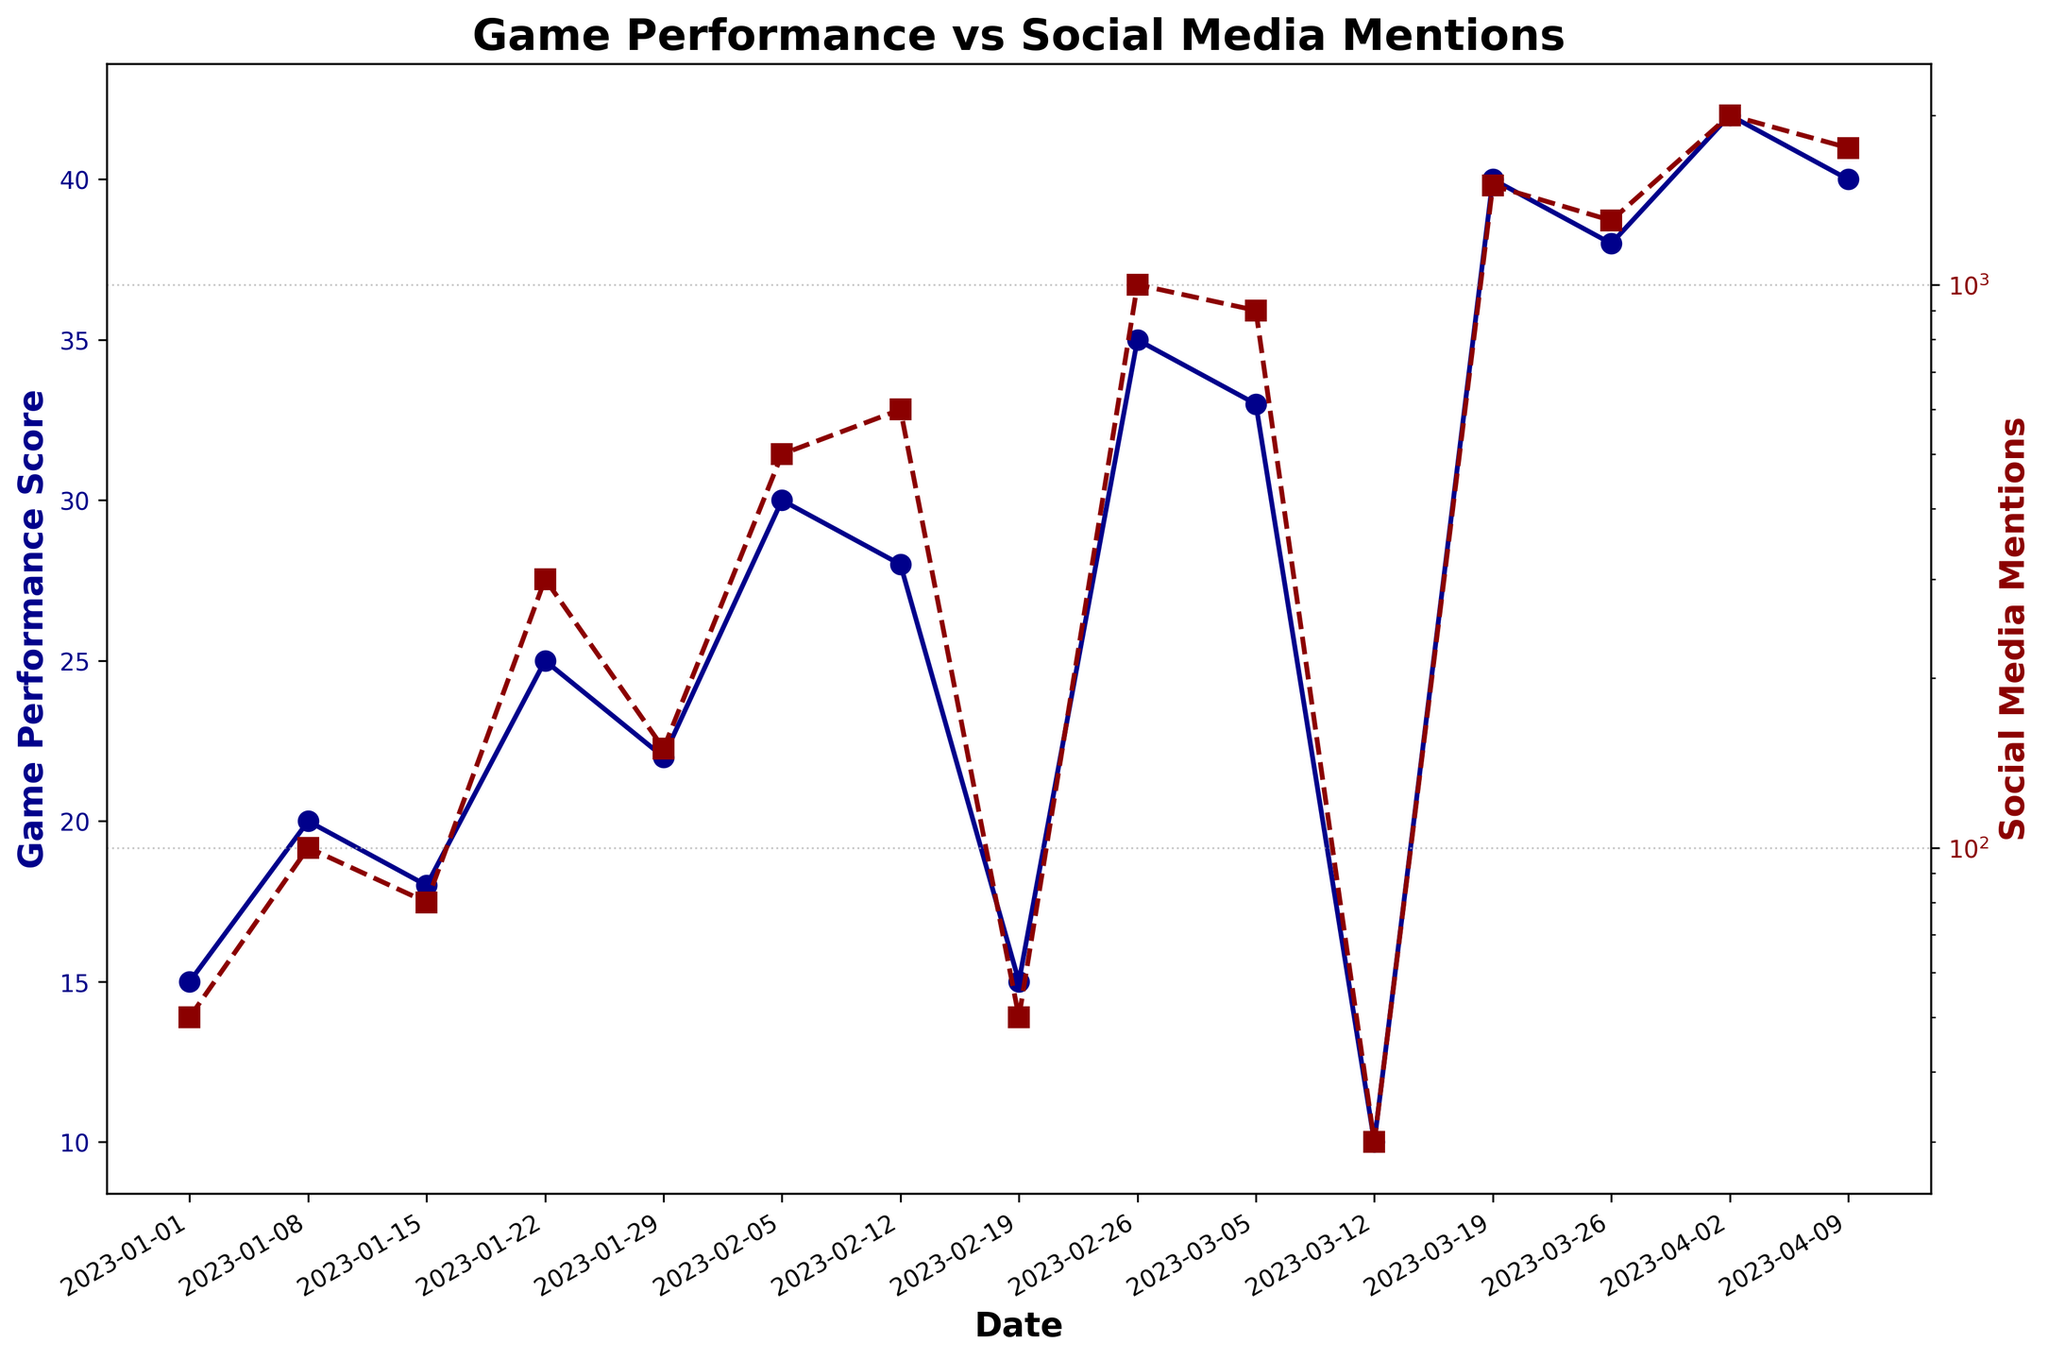what is the title of the figure? The title is typically at the top of the figure, styled in a larger and bolder font.
Answer: Game Performance vs Social Media Mentions How many data points are in the figure? Each date marks a data point, and you can count them along the x-axis.
Answer: 15 What is the highest "Game Performance Score" shown on the figure? Look at the y-axis corresponding to "Game Performance Score". The highest point visually can be identified among the points marked.
Answer: 42 Which date had the highest "Social Media Mentions"? Look at the "Social Media Mentions" line, and find the peak value. Match this peak with the date on the x-axis.
Answer: 2023-04-02 On what date did the "Game Performance Score" have a major dip, and what was the corresponding "Social Media Mentions"? Look for a significant drop in the "Game Performance Score" line and then check that date on the "Social Media Mentions" line.
Answer: 2023-03-12, 30 What is the average "Game Performance Score" for the first five data points? Sum the "Game Performance Scores" for the first five data points and divide by five. (15+20+18+25+22)/5 = 20
Answer: 20 Compare the "Social Media Mentions" on 2023-02-12 and 2023-03-12, which is higher and by how much? Identify the value of "Social Media Mentions" on both dates and calculate the difference. (600 - 30)
Answer: 2023-02-12 by 570 Does the "Game Performance Score" show a visible positive trend over time? Examine the general direction of the "Game Performance Score" line over time to see if it rises overall.
Answer: Yes How does the "Social Media Mentions" trend compare with the "Game Performance Score" trend? Compare the directions of both lines to see if they rise and fall together.
Answer: Generally positive, closely correlated Does the logarithmic scale of "Social Media Mentions" affect the interpretation of growth trends? Logarithmic scales can compress large ranges of data, making exponential growth appear more linear. This helps in visualizing rapid changes over large ranges.
Answer: Yes, it compresses data 